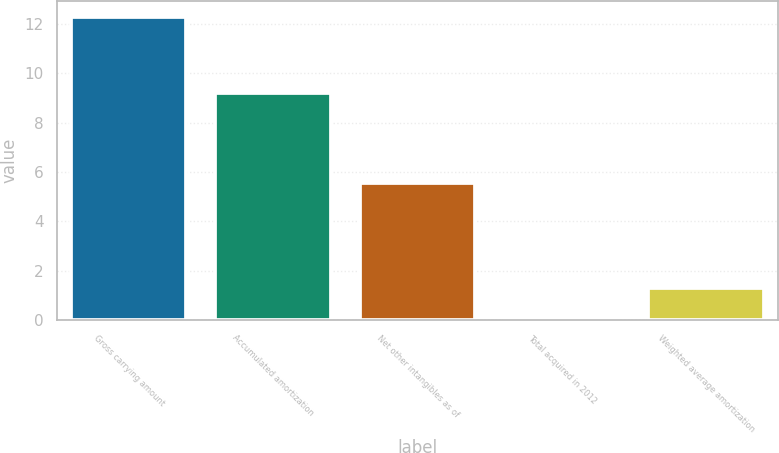<chart> <loc_0><loc_0><loc_500><loc_500><bar_chart><fcel>Gross carrying amount<fcel>Accumulated amortization<fcel>Net other intangibles as of<fcel>Total acquired in 2012<fcel>Weighted average amortization<nl><fcel>12.3<fcel>9.2<fcel>5.54<fcel>0.1<fcel>1.32<nl></chart> 